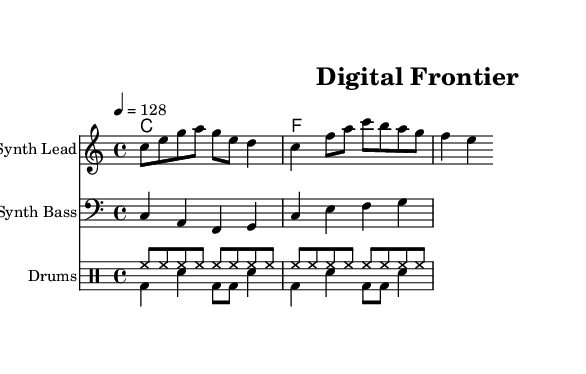What is the key signature of this music? The key signature is C major, which has no sharps or flats, indicated at the beginning of the staff.
Answer: C major What is the time signature of this music? The time signature is 4/4, shown at the beginning of the score, indicating four beats per measure and a quarter note receives one beat.
Answer: 4/4 What is the tempo marking for this piece? The tempo is specified as 4 = 128, indicating that there are 128 beats per minute, and the quarter note is counted as one beat.
Answer: 128 How many measures are in the melody? By counting the bars in the melody section, we can see there are four measures. Each section of music separated by vertical lines represents one measure.
Answer: 4 What is the instrument used for the melody? The melody is written for a staff labeled "Synth Lead," which indicates that this part will be played using a synthesizer lead sound.
Answer: Synth Lead How many different drum patterns are present in the score? There are two distinct drum patterns visible in the drum staff, one labeled as "drumPatternUp" and the other as "drumPatternDown," with different rhythms.
Answer: 2 What harmonic structure is present in the score? The harmonic structure consists of two chords: C major for the first measure and F major for the second, known as a simple diatonic progression.
Answer: C and F 